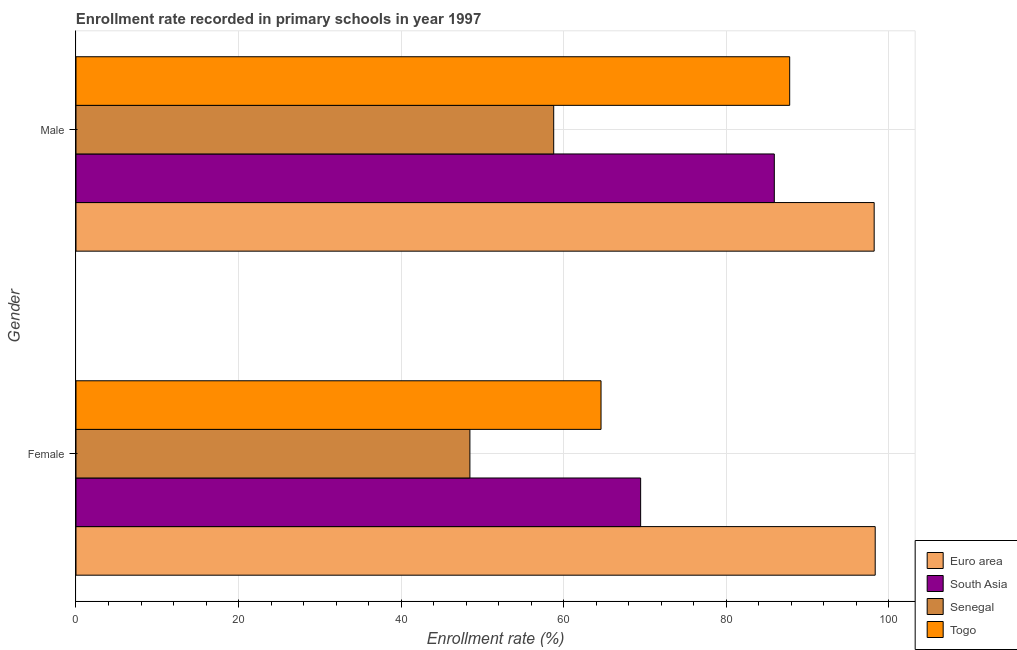How many different coloured bars are there?
Provide a short and direct response. 4. How many groups of bars are there?
Provide a succinct answer. 2. How many bars are there on the 1st tick from the top?
Your answer should be compact. 4. How many bars are there on the 2nd tick from the bottom?
Your answer should be very brief. 4. What is the enrollment rate of female students in South Asia?
Your response must be concise. 69.48. Across all countries, what is the maximum enrollment rate of male students?
Keep it short and to the point. 98.22. Across all countries, what is the minimum enrollment rate of female students?
Give a very brief answer. 48.47. In which country was the enrollment rate of male students minimum?
Make the answer very short. Senegal. What is the total enrollment rate of male students in the graph?
Your response must be concise. 330.76. What is the difference between the enrollment rate of male students in South Asia and that in Euro area?
Make the answer very short. -12.29. What is the difference between the enrollment rate of male students in Senegal and the enrollment rate of female students in Togo?
Keep it short and to the point. -5.82. What is the average enrollment rate of female students per country?
Offer a very short reply. 70.23. What is the difference between the enrollment rate of male students and enrollment rate of female students in South Asia?
Your answer should be compact. 16.45. In how many countries, is the enrollment rate of male students greater than 64 %?
Offer a terse response. 3. What is the ratio of the enrollment rate of male students in Euro area to that in South Asia?
Ensure brevity in your answer.  1.14. In how many countries, is the enrollment rate of male students greater than the average enrollment rate of male students taken over all countries?
Ensure brevity in your answer.  3. What does the 1st bar from the top in Female represents?
Offer a terse response. Togo. What does the 4th bar from the bottom in Male represents?
Offer a terse response. Togo. How many bars are there?
Make the answer very short. 8. Are all the bars in the graph horizontal?
Offer a very short reply. Yes. How many countries are there in the graph?
Keep it short and to the point. 4. What is the difference between two consecutive major ticks on the X-axis?
Your response must be concise. 20. Are the values on the major ticks of X-axis written in scientific E-notation?
Provide a short and direct response. No. Does the graph contain any zero values?
Provide a succinct answer. No. Does the graph contain grids?
Give a very brief answer. Yes. Where does the legend appear in the graph?
Provide a succinct answer. Bottom right. How are the legend labels stacked?
Give a very brief answer. Vertical. What is the title of the graph?
Your answer should be very brief. Enrollment rate recorded in primary schools in year 1997. What is the label or title of the X-axis?
Give a very brief answer. Enrollment rate (%). What is the Enrollment rate (%) in Euro area in Female?
Offer a very short reply. 98.35. What is the Enrollment rate (%) of South Asia in Female?
Offer a terse response. 69.48. What is the Enrollment rate (%) of Senegal in Female?
Your answer should be very brief. 48.47. What is the Enrollment rate (%) in Togo in Female?
Your answer should be very brief. 64.61. What is the Enrollment rate (%) of Euro area in Male?
Ensure brevity in your answer.  98.22. What is the Enrollment rate (%) in South Asia in Male?
Your answer should be compact. 85.93. What is the Enrollment rate (%) in Senegal in Male?
Offer a terse response. 58.78. What is the Enrollment rate (%) in Togo in Male?
Provide a succinct answer. 87.82. Across all Gender, what is the maximum Enrollment rate (%) of Euro area?
Give a very brief answer. 98.35. Across all Gender, what is the maximum Enrollment rate (%) in South Asia?
Give a very brief answer. 85.93. Across all Gender, what is the maximum Enrollment rate (%) of Senegal?
Offer a very short reply. 58.78. Across all Gender, what is the maximum Enrollment rate (%) in Togo?
Your response must be concise. 87.82. Across all Gender, what is the minimum Enrollment rate (%) in Euro area?
Offer a very short reply. 98.22. Across all Gender, what is the minimum Enrollment rate (%) in South Asia?
Keep it short and to the point. 69.48. Across all Gender, what is the minimum Enrollment rate (%) of Senegal?
Provide a short and direct response. 48.47. Across all Gender, what is the minimum Enrollment rate (%) in Togo?
Keep it short and to the point. 64.61. What is the total Enrollment rate (%) in Euro area in the graph?
Your response must be concise. 196.56. What is the total Enrollment rate (%) of South Asia in the graph?
Offer a terse response. 155.41. What is the total Enrollment rate (%) in Senegal in the graph?
Give a very brief answer. 107.26. What is the total Enrollment rate (%) of Togo in the graph?
Your answer should be compact. 152.43. What is the difference between the Enrollment rate (%) of Euro area in Female and that in Male?
Your answer should be very brief. 0.13. What is the difference between the Enrollment rate (%) in South Asia in Female and that in Male?
Give a very brief answer. -16.45. What is the difference between the Enrollment rate (%) in Senegal in Female and that in Male?
Provide a short and direct response. -10.31. What is the difference between the Enrollment rate (%) in Togo in Female and that in Male?
Offer a terse response. -23.22. What is the difference between the Enrollment rate (%) of Euro area in Female and the Enrollment rate (%) of South Asia in Male?
Offer a terse response. 12.41. What is the difference between the Enrollment rate (%) in Euro area in Female and the Enrollment rate (%) in Senegal in Male?
Provide a succinct answer. 39.56. What is the difference between the Enrollment rate (%) of Euro area in Female and the Enrollment rate (%) of Togo in Male?
Provide a short and direct response. 10.52. What is the difference between the Enrollment rate (%) in South Asia in Female and the Enrollment rate (%) in Senegal in Male?
Offer a very short reply. 10.7. What is the difference between the Enrollment rate (%) of South Asia in Female and the Enrollment rate (%) of Togo in Male?
Your response must be concise. -18.34. What is the difference between the Enrollment rate (%) of Senegal in Female and the Enrollment rate (%) of Togo in Male?
Keep it short and to the point. -39.35. What is the average Enrollment rate (%) in Euro area per Gender?
Your answer should be compact. 98.28. What is the average Enrollment rate (%) in South Asia per Gender?
Make the answer very short. 77.71. What is the average Enrollment rate (%) of Senegal per Gender?
Provide a succinct answer. 53.63. What is the average Enrollment rate (%) in Togo per Gender?
Your answer should be very brief. 76.22. What is the difference between the Enrollment rate (%) in Euro area and Enrollment rate (%) in South Asia in Female?
Your answer should be very brief. 28.86. What is the difference between the Enrollment rate (%) of Euro area and Enrollment rate (%) of Senegal in Female?
Offer a very short reply. 49.87. What is the difference between the Enrollment rate (%) in Euro area and Enrollment rate (%) in Togo in Female?
Give a very brief answer. 33.74. What is the difference between the Enrollment rate (%) in South Asia and Enrollment rate (%) in Senegal in Female?
Your answer should be compact. 21.01. What is the difference between the Enrollment rate (%) in South Asia and Enrollment rate (%) in Togo in Female?
Your answer should be compact. 4.88. What is the difference between the Enrollment rate (%) of Senegal and Enrollment rate (%) of Togo in Female?
Keep it short and to the point. -16.13. What is the difference between the Enrollment rate (%) of Euro area and Enrollment rate (%) of South Asia in Male?
Provide a short and direct response. 12.29. What is the difference between the Enrollment rate (%) in Euro area and Enrollment rate (%) in Senegal in Male?
Your answer should be compact. 39.44. What is the difference between the Enrollment rate (%) in Euro area and Enrollment rate (%) in Togo in Male?
Ensure brevity in your answer.  10.4. What is the difference between the Enrollment rate (%) in South Asia and Enrollment rate (%) in Senegal in Male?
Give a very brief answer. 27.15. What is the difference between the Enrollment rate (%) in South Asia and Enrollment rate (%) in Togo in Male?
Offer a very short reply. -1.89. What is the difference between the Enrollment rate (%) in Senegal and Enrollment rate (%) in Togo in Male?
Provide a succinct answer. -29.04. What is the ratio of the Enrollment rate (%) in Euro area in Female to that in Male?
Your answer should be very brief. 1. What is the ratio of the Enrollment rate (%) of South Asia in Female to that in Male?
Your response must be concise. 0.81. What is the ratio of the Enrollment rate (%) in Senegal in Female to that in Male?
Keep it short and to the point. 0.82. What is the ratio of the Enrollment rate (%) in Togo in Female to that in Male?
Offer a terse response. 0.74. What is the difference between the highest and the second highest Enrollment rate (%) of Euro area?
Make the answer very short. 0.13. What is the difference between the highest and the second highest Enrollment rate (%) of South Asia?
Offer a terse response. 16.45. What is the difference between the highest and the second highest Enrollment rate (%) in Senegal?
Offer a terse response. 10.31. What is the difference between the highest and the second highest Enrollment rate (%) in Togo?
Ensure brevity in your answer.  23.22. What is the difference between the highest and the lowest Enrollment rate (%) of Euro area?
Provide a short and direct response. 0.13. What is the difference between the highest and the lowest Enrollment rate (%) in South Asia?
Keep it short and to the point. 16.45. What is the difference between the highest and the lowest Enrollment rate (%) of Senegal?
Your answer should be compact. 10.31. What is the difference between the highest and the lowest Enrollment rate (%) in Togo?
Ensure brevity in your answer.  23.22. 